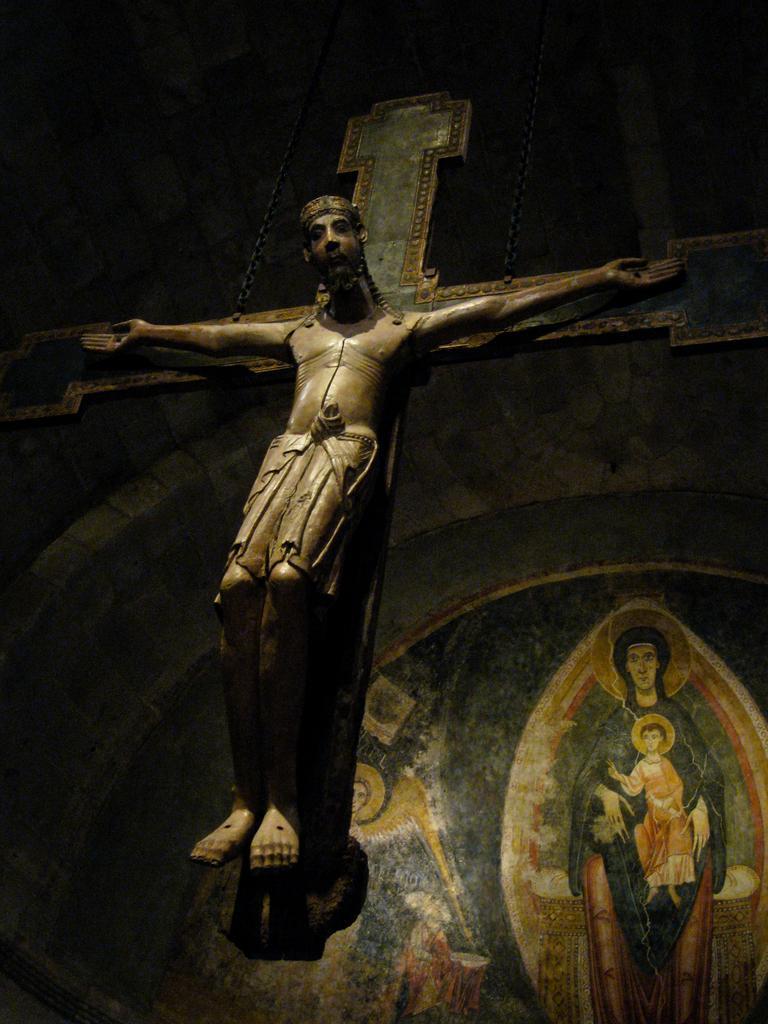How would you summarize this image in a sentence or two? In this image I can see a statue of the Jesus. Here I can see painting on the wall. 